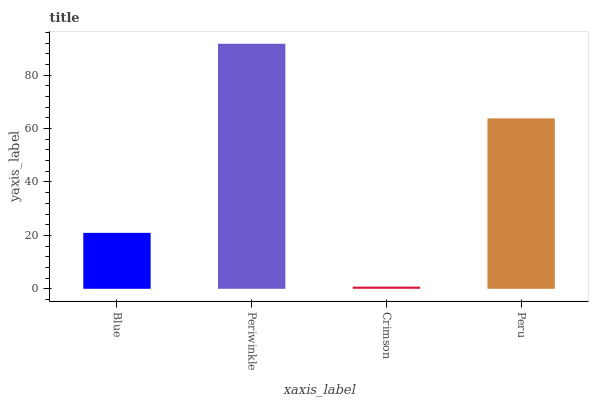Is Crimson the minimum?
Answer yes or no. Yes. Is Periwinkle the maximum?
Answer yes or no. Yes. Is Periwinkle the minimum?
Answer yes or no. No. Is Crimson the maximum?
Answer yes or no. No. Is Periwinkle greater than Crimson?
Answer yes or no. Yes. Is Crimson less than Periwinkle?
Answer yes or no. Yes. Is Crimson greater than Periwinkle?
Answer yes or no. No. Is Periwinkle less than Crimson?
Answer yes or no. No. Is Peru the high median?
Answer yes or no. Yes. Is Blue the low median?
Answer yes or no. Yes. Is Crimson the high median?
Answer yes or no. No. Is Crimson the low median?
Answer yes or no. No. 